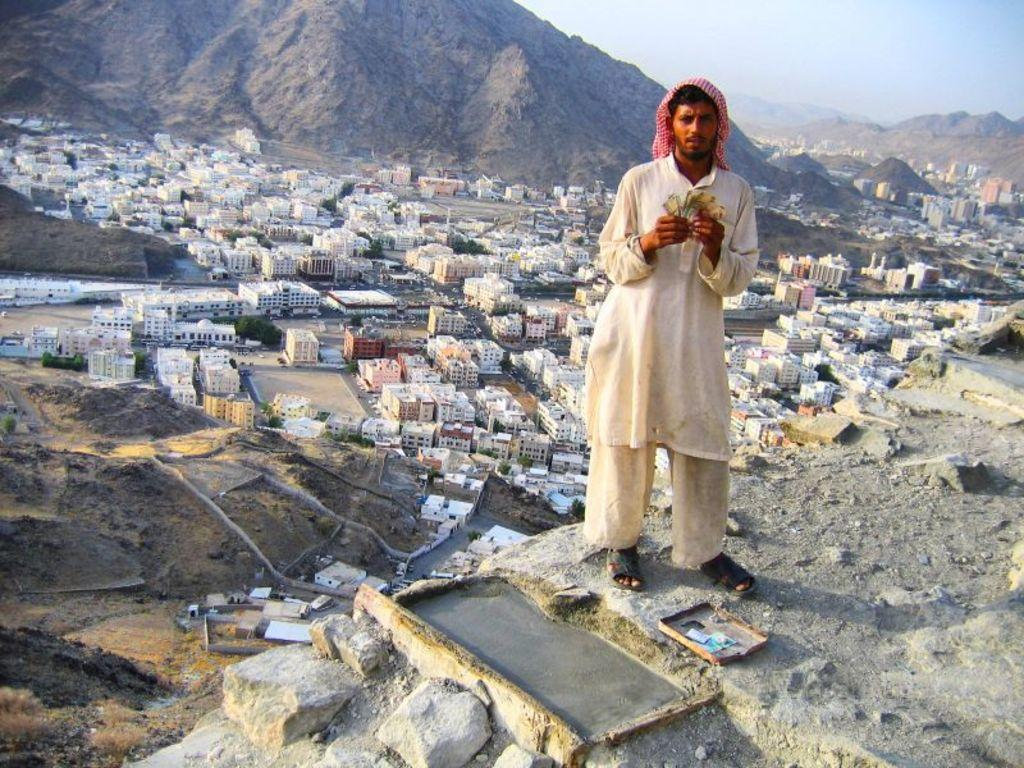What is the main subject of the image? There is a person standing in the image. What is the person holding in the image? The person is holding an object. What can be seen on the land in the image? There are buildings on the land in the image. What type of natural feature is visible in the background of the image? There are hills in the background of the image. What part of the sky is visible in the image? The sky is visible at the top right of the image. What type of steel book can be seen in the person's hand in the image? There is no steel book present in the image; the person is holding an unspecified object. 